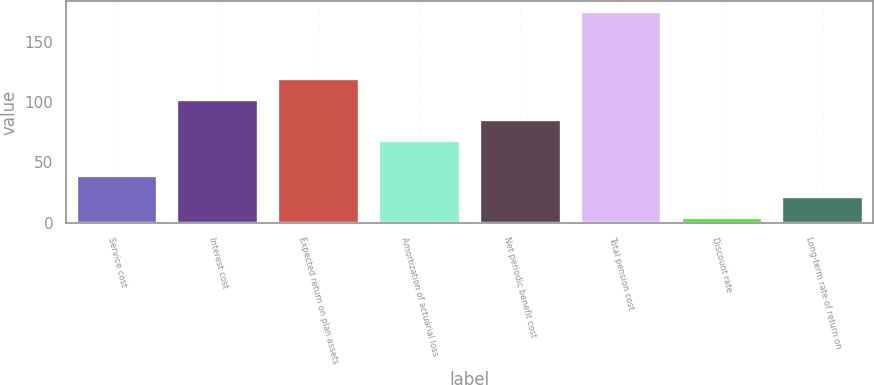Convert chart. <chart><loc_0><loc_0><loc_500><loc_500><bar_chart><fcel>Service cost<fcel>Interest cost<fcel>Expected return on plan assets<fcel>Amortization of actuarial loss<fcel>Net periodic benefit cost<fcel>Total pension cost<fcel>Discount rate<fcel>Long-term rate of return on<nl><fcel>38.32<fcel>102.18<fcel>119.27<fcel>68<fcel>85.09<fcel>175<fcel>4.14<fcel>21.23<nl></chart> 